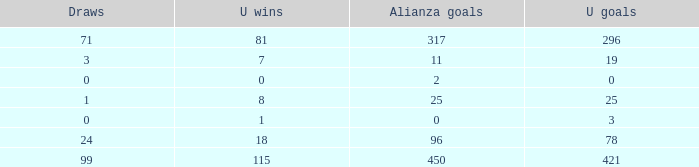Would you mind parsing the complete table? {'header': ['Draws', 'U wins', 'Alianza goals', 'U goals'], 'rows': [['71', '81', '317', '296'], ['3', '7', '11', '19'], ['0', '0', '2', '0'], ['1', '8', '25', '25'], ['0', '1', '0', '3'], ['24', '18', '96', '78'], ['99', '115', '450', '421']]} What is the lowest U Wins, when Alianza Wins is greater than 0, when Alianza Goals is greater than 25, and when Draws is "99"? 115.0. 